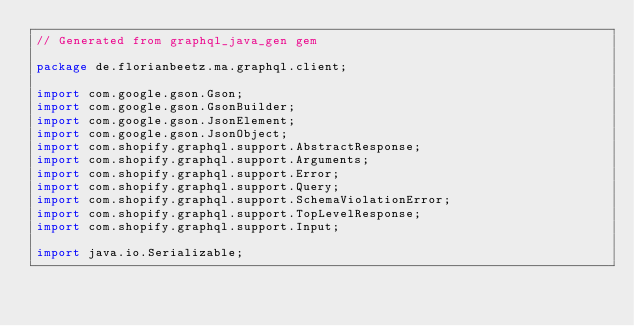<code> <loc_0><loc_0><loc_500><loc_500><_Java_>// Generated from graphql_java_gen gem

package de.florianbeetz.ma.graphql.client;

import com.google.gson.Gson;
import com.google.gson.GsonBuilder;
import com.google.gson.JsonElement;
import com.google.gson.JsonObject;
import com.shopify.graphql.support.AbstractResponse;
import com.shopify.graphql.support.Arguments;
import com.shopify.graphql.support.Error;
import com.shopify.graphql.support.Query;
import com.shopify.graphql.support.SchemaViolationError;
import com.shopify.graphql.support.TopLevelResponse;
import com.shopify.graphql.support.Input;

import java.io.Serializable;</code> 